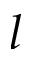Convert formula to latex. <formula><loc_0><loc_0><loc_500><loc_500>l</formula> 